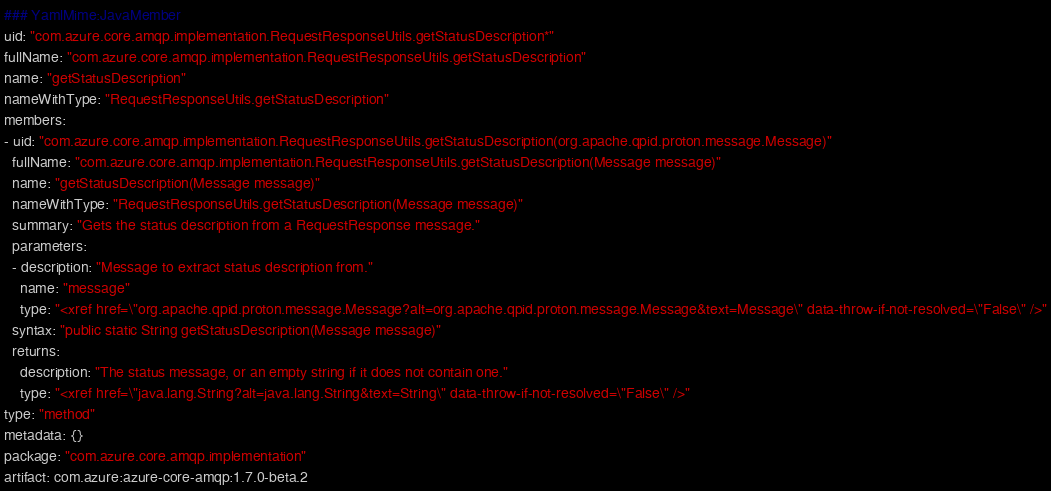Convert code to text. <code><loc_0><loc_0><loc_500><loc_500><_YAML_>### YamlMime:JavaMember
uid: "com.azure.core.amqp.implementation.RequestResponseUtils.getStatusDescription*"
fullName: "com.azure.core.amqp.implementation.RequestResponseUtils.getStatusDescription"
name: "getStatusDescription"
nameWithType: "RequestResponseUtils.getStatusDescription"
members:
- uid: "com.azure.core.amqp.implementation.RequestResponseUtils.getStatusDescription(org.apache.qpid.proton.message.Message)"
  fullName: "com.azure.core.amqp.implementation.RequestResponseUtils.getStatusDescription(Message message)"
  name: "getStatusDescription(Message message)"
  nameWithType: "RequestResponseUtils.getStatusDescription(Message message)"
  summary: "Gets the status description from a RequestResponse message."
  parameters:
  - description: "Message to extract status description from."
    name: "message"
    type: "<xref href=\"org.apache.qpid.proton.message.Message?alt=org.apache.qpid.proton.message.Message&text=Message\" data-throw-if-not-resolved=\"False\" />"
  syntax: "public static String getStatusDescription(Message message)"
  returns:
    description: "The status message, or an empty string if it does not contain one."
    type: "<xref href=\"java.lang.String?alt=java.lang.String&text=String\" data-throw-if-not-resolved=\"False\" />"
type: "method"
metadata: {}
package: "com.azure.core.amqp.implementation"
artifact: com.azure:azure-core-amqp:1.7.0-beta.2
</code> 